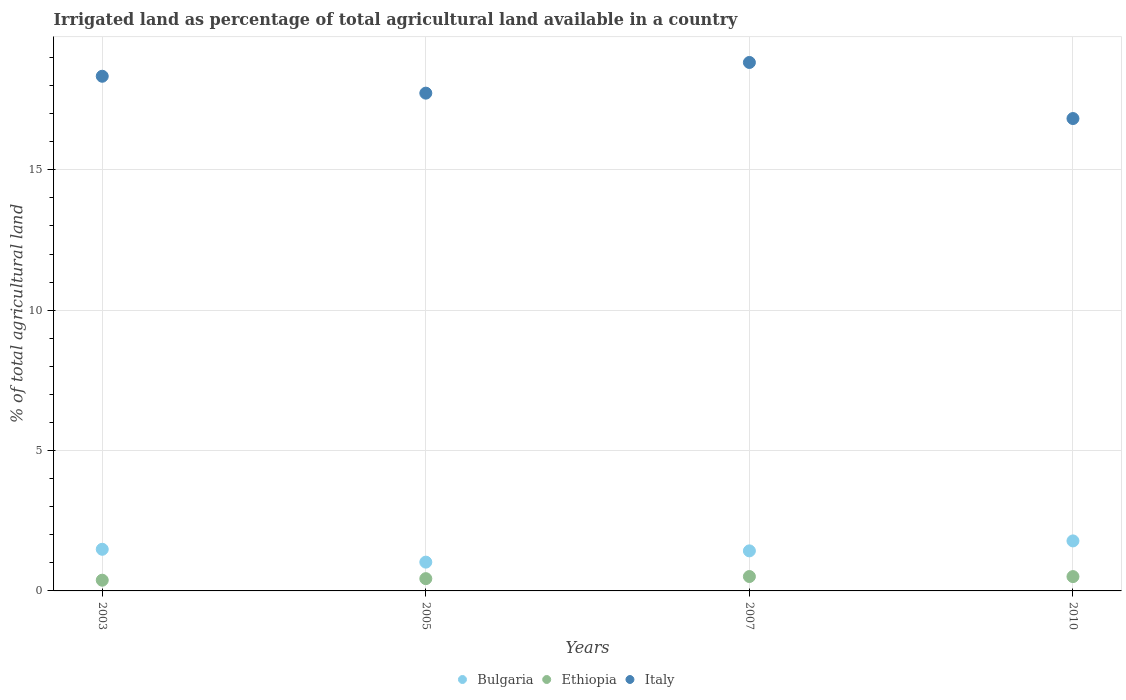How many different coloured dotlines are there?
Your answer should be very brief. 3. Is the number of dotlines equal to the number of legend labels?
Your answer should be compact. Yes. What is the percentage of irrigated land in Ethiopia in 2003?
Ensure brevity in your answer.  0.38. Across all years, what is the maximum percentage of irrigated land in Italy?
Keep it short and to the point. 18.83. Across all years, what is the minimum percentage of irrigated land in Bulgaria?
Offer a very short reply. 1.03. In which year was the percentage of irrigated land in Bulgaria maximum?
Provide a short and direct response. 2010. What is the total percentage of irrigated land in Ethiopia in the graph?
Give a very brief answer. 1.84. What is the difference between the percentage of irrigated land in Bulgaria in 2007 and that in 2010?
Your response must be concise. -0.35. What is the difference between the percentage of irrigated land in Ethiopia in 2003 and the percentage of irrigated land in Italy in 2007?
Keep it short and to the point. -18.44. What is the average percentage of irrigated land in Italy per year?
Give a very brief answer. 17.93. In the year 2003, what is the difference between the percentage of irrigated land in Italy and percentage of irrigated land in Bulgaria?
Provide a succinct answer. 16.85. What is the ratio of the percentage of irrigated land in Bulgaria in 2003 to that in 2010?
Make the answer very short. 0.83. What is the difference between the highest and the second highest percentage of irrigated land in Italy?
Your response must be concise. 0.49. What is the difference between the highest and the lowest percentage of irrigated land in Bulgaria?
Provide a succinct answer. 0.76. In how many years, is the percentage of irrigated land in Ethiopia greater than the average percentage of irrigated land in Ethiopia taken over all years?
Provide a succinct answer. 2. Is the sum of the percentage of irrigated land in Ethiopia in 2005 and 2010 greater than the maximum percentage of irrigated land in Bulgaria across all years?
Keep it short and to the point. No. Is it the case that in every year, the sum of the percentage of irrigated land in Bulgaria and percentage of irrigated land in Italy  is greater than the percentage of irrigated land in Ethiopia?
Provide a short and direct response. Yes. Does the percentage of irrigated land in Italy monotonically increase over the years?
Your response must be concise. No. Is the percentage of irrigated land in Italy strictly greater than the percentage of irrigated land in Bulgaria over the years?
Your answer should be very brief. Yes. Is the percentage of irrigated land in Italy strictly less than the percentage of irrigated land in Ethiopia over the years?
Provide a succinct answer. No. What is the difference between two consecutive major ticks on the Y-axis?
Keep it short and to the point. 5. Does the graph contain any zero values?
Provide a succinct answer. No. Does the graph contain grids?
Make the answer very short. Yes. Where does the legend appear in the graph?
Your answer should be very brief. Bottom center. How are the legend labels stacked?
Provide a succinct answer. Horizontal. What is the title of the graph?
Your answer should be compact. Irrigated land as percentage of total agricultural land available in a country. What is the label or title of the X-axis?
Offer a terse response. Years. What is the label or title of the Y-axis?
Provide a short and direct response. % of total agricultural land. What is the % of total agricultural land in Bulgaria in 2003?
Offer a very short reply. 1.48. What is the % of total agricultural land in Ethiopia in 2003?
Keep it short and to the point. 0.38. What is the % of total agricultural land of Italy in 2003?
Your answer should be very brief. 18.33. What is the % of total agricultural land of Bulgaria in 2005?
Keep it short and to the point. 1.03. What is the % of total agricultural land in Ethiopia in 2005?
Provide a short and direct response. 0.44. What is the % of total agricultural land of Italy in 2005?
Ensure brevity in your answer.  17.73. What is the % of total agricultural land of Bulgaria in 2007?
Ensure brevity in your answer.  1.43. What is the % of total agricultural land of Ethiopia in 2007?
Your response must be concise. 0.51. What is the % of total agricultural land in Italy in 2007?
Your response must be concise. 18.83. What is the % of total agricultural land of Bulgaria in 2010?
Your response must be concise. 1.78. What is the % of total agricultural land in Ethiopia in 2010?
Your answer should be very brief. 0.51. What is the % of total agricultural land in Italy in 2010?
Provide a succinct answer. 16.83. Across all years, what is the maximum % of total agricultural land of Bulgaria?
Make the answer very short. 1.78. Across all years, what is the maximum % of total agricultural land in Ethiopia?
Keep it short and to the point. 0.51. Across all years, what is the maximum % of total agricultural land of Italy?
Ensure brevity in your answer.  18.83. Across all years, what is the minimum % of total agricultural land in Bulgaria?
Make the answer very short. 1.03. Across all years, what is the minimum % of total agricultural land of Ethiopia?
Your response must be concise. 0.38. Across all years, what is the minimum % of total agricultural land of Italy?
Your answer should be compact. 16.83. What is the total % of total agricultural land of Bulgaria in the graph?
Provide a short and direct response. 5.72. What is the total % of total agricultural land in Ethiopia in the graph?
Your answer should be compact. 1.84. What is the total % of total agricultural land of Italy in the graph?
Give a very brief answer. 71.72. What is the difference between the % of total agricultural land of Bulgaria in 2003 and that in 2005?
Provide a short and direct response. 0.46. What is the difference between the % of total agricultural land of Ethiopia in 2003 and that in 2005?
Keep it short and to the point. -0.06. What is the difference between the % of total agricultural land in Italy in 2003 and that in 2005?
Make the answer very short. 0.6. What is the difference between the % of total agricultural land of Bulgaria in 2003 and that in 2007?
Your response must be concise. 0.06. What is the difference between the % of total agricultural land in Ethiopia in 2003 and that in 2007?
Provide a succinct answer. -0.13. What is the difference between the % of total agricultural land of Italy in 2003 and that in 2007?
Provide a short and direct response. -0.49. What is the difference between the % of total agricultural land of Bulgaria in 2003 and that in 2010?
Offer a terse response. -0.3. What is the difference between the % of total agricultural land of Ethiopia in 2003 and that in 2010?
Provide a short and direct response. -0.13. What is the difference between the % of total agricultural land in Italy in 2003 and that in 2010?
Provide a succinct answer. 1.51. What is the difference between the % of total agricultural land of Bulgaria in 2005 and that in 2007?
Keep it short and to the point. -0.4. What is the difference between the % of total agricultural land in Ethiopia in 2005 and that in 2007?
Your answer should be compact. -0.08. What is the difference between the % of total agricultural land of Italy in 2005 and that in 2007?
Offer a very short reply. -1.09. What is the difference between the % of total agricultural land in Bulgaria in 2005 and that in 2010?
Ensure brevity in your answer.  -0.76. What is the difference between the % of total agricultural land in Ethiopia in 2005 and that in 2010?
Your answer should be compact. -0.07. What is the difference between the % of total agricultural land in Italy in 2005 and that in 2010?
Give a very brief answer. 0.9. What is the difference between the % of total agricultural land in Bulgaria in 2007 and that in 2010?
Ensure brevity in your answer.  -0.35. What is the difference between the % of total agricultural land in Ethiopia in 2007 and that in 2010?
Provide a short and direct response. 0. What is the difference between the % of total agricultural land in Italy in 2007 and that in 2010?
Make the answer very short. 2. What is the difference between the % of total agricultural land in Bulgaria in 2003 and the % of total agricultural land in Ethiopia in 2005?
Provide a short and direct response. 1.05. What is the difference between the % of total agricultural land in Bulgaria in 2003 and the % of total agricultural land in Italy in 2005?
Your answer should be very brief. -16.25. What is the difference between the % of total agricultural land of Ethiopia in 2003 and the % of total agricultural land of Italy in 2005?
Your answer should be compact. -17.35. What is the difference between the % of total agricultural land in Bulgaria in 2003 and the % of total agricultural land in Ethiopia in 2007?
Provide a succinct answer. 0.97. What is the difference between the % of total agricultural land in Bulgaria in 2003 and the % of total agricultural land in Italy in 2007?
Your answer should be very brief. -17.34. What is the difference between the % of total agricultural land in Ethiopia in 2003 and the % of total agricultural land in Italy in 2007?
Provide a short and direct response. -18.44. What is the difference between the % of total agricultural land in Bulgaria in 2003 and the % of total agricultural land in Ethiopia in 2010?
Your answer should be compact. 0.97. What is the difference between the % of total agricultural land of Bulgaria in 2003 and the % of total agricultural land of Italy in 2010?
Keep it short and to the point. -15.34. What is the difference between the % of total agricultural land in Ethiopia in 2003 and the % of total agricultural land in Italy in 2010?
Keep it short and to the point. -16.45. What is the difference between the % of total agricultural land of Bulgaria in 2005 and the % of total agricultural land of Ethiopia in 2007?
Your response must be concise. 0.51. What is the difference between the % of total agricultural land of Bulgaria in 2005 and the % of total agricultural land of Italy in 2007?
Offer a very short reply. -17.8. What is the difference between the % of total agricultural land of Ethiopia in 2005 and the % of total agricultural land of Italy in 2007?
Your answer should be compact. -18.39. What is the difference between the % of total agricultural land of Bulgaria in 2005 and the % of total agricultural land of Ethiopia in 2010?
Offer a very short reply. 0.52. What is the difference between the % of total agricultural land in Bulgaria in 2005 and the % of total agricultural land in Italy in 2010?
Make the answer very short. -15.8. What is the difference between the % of total agricultural land in Ethiopia in 2005 and the % of total agricultural land in Italy in 2010?
Give a very brief answer. -16.39. What is the difference between the % of total agricultural land in Bulgaria in 2007 and the % of total agricultural land in Ethiopia in 2010?
Offer a very short reply. 0.92. What is the difference between the % of total agricultural land of Bulgaria in 2007 and the % of total agricultural land of Italy in 2010?
Keep it short and to the point. -15.4. What is the difference between the % of total agricultural land of Ethiopia in 2007 and the % of total agricultural land of Italy in 2010?
Offer a terse response. -16.31. What is the average % of total agricultural land in Bulgaria per year?
Keep it short and to the point. 1.43. What is the average % of total agricultural land of Ethiopia per year?
Provide a succinct answer. 0.46. What is the average % of total agricultural land in Italy per year?
Offer a very short reply. 17.93. In the year 2003, what is the difference between the % of total agricultural land of Bulgaria and % of total agricultural land of Ethiopia?
Ensure brevity in your answer.  1.1. In the year 2003, what is the difference between the % of total agricultural land in Bulgaria and % of total agricultural land in Italy?
Your answer should be compact. -16.85. In the year 2003, what is the difference between the % of total agricultural land in Ethiopia and % of total agricultural land in Italy?
Keep it short and to the point. -17.95. In the year 2005, what is the difference between the % of total agricultural land in Bulgaria and % of total agricultural land in Ethiopia?
Your response must be concise. 0.59. In the year 2005, what is the difference between the % of total agricultural land in Bulgaria and % of total agricultural land in Italy?
Make the answer very short. -16.71. In the year 2005, what is the difference between the % of total agricultural land of Ethiopia and % of total agricultural land of Italy?
Keep it short and to the point. -17.29. In the year 2007, what is the difference between the % of total agricultural land in Bulgaria and % of total agricultural land in Ethiopia?
Offer a terse response. 0.91. In the year 2007, what is the difference between the % of total agricultural land of Bulgaria and % of total agricultural land of Italy?
Keep it short and to the point. -17.4. In the year 2007, what is the difference between the % of total agricultural land in Ethiopia and % of total agricultural land in Italy?
Your answer should be very brief. -18.31. In the year 2010, what is the difference between the % of total agricultural land of Bulgaria and % of total agricultural land of Ethiopia?
Offer a very short reply. 1.27. In the year 2010, what is the difference between the % of total agricultural land of Bulgaria and % of total agricultural land of Italy?
Provide a short and direct response. -15.05. In the year 2010, what is the difference between the % of total agricultural land in Ethiopia and % of total agricultural land in Italy?
Offer a terse response. -16.32. What is the ratio of the % of total agricultural land in Bulgaria in 2003 to that in 2005?
Ensure brevity in your answer.  1.45. What is the ratio of the % of total agricultural land in Ethiopia in 2003 to that in 2005?
Provide a short and direct response. 0.87. What is the ratio of the % of total agricultural land in Italy in 2003 to that in 2005?
Offer a terse response. 1.03. What is the ratio of the % of total agricultural land of Bulgaria in 2003 to that in 2007?
Offer a very short reply. 1.04. What is the ratio of the % of total agricultural land in Ethiopia in 2003 to that in 2007?
Offer a terse response. 0.74. What is the ratio of the % of total agricultural land in Italy in 2003 to that in 2007?
Ensure brevity in your answer.  0.97. What is the ratio of the % of total agricultural land of Bulgaria in 2003 to that in 2010?
Give a very brief answer. 0.83. What is the ratio of the % of total agricultural land of Ethiopia in 2003 to that in 2010?
Your answer should be very brief. 0.75. What is the ratio of the % of total agricultural land of Italy in 2003 to that in 2010?
Keep it short and to the point. 1.09. What is the ratio of the % of total agricultural land in Bulgaria in 2005 to that in 2007?
Your answer should be compact. 0.72. What is the ratio of the % of total agricultural land in Ethiopia in 2005 to that in 2007?
Offer a terse response. 0.85. What is the ratio of the % of total agricultural land in Italy in 2005 to that in 2007?
Provide a succinct answer. 0.94. What is the ratio of the % of total agricultural land of Bulgaria in 2005 to that in 2010?
Ensure brevity in your answer.  0.58. What is the ratio of the % of total agricultural land of Ethiopia in 2005 to that in 2010?
Provide a short and direct response. 0.86. What is the ratio of the % of total agricultural land of Italy in 2005 to that in 2010?
Give a very brief answer. 1.05. What is the ratio of the % of total agricultural land in Bulgaria in 2007 to that in 2010?
Your answer should be very brief. 0.8. What is the ratio of the % of total agricultural land of Italy in 2007 to that in 2010?
Make the answer very short. 1.12. What is the difference between the highest and the second highest % of total agricultural land in Bulgaria?
Your response must be concise. 0.3. What is the difference between the highest and the second highest % of total agricultural land in Ethiopia?
Offer a very short reply. 0. What is the difference between the highest and the second highest % of total agricultural land of Italy?
Make the answer very short. 0.49. What is the difference between the highest and the lowest % of total agricultural land of Bulgaria?
Your answer should be compact. 0.76. What is the difference between the highest and the lowest % of total agricultural land in Ethiopia?
Your response must be concise. 0.13. What is the difference between the highest and the lowest % of total agricultural land of Italy?
Offer a terse response. 2. 